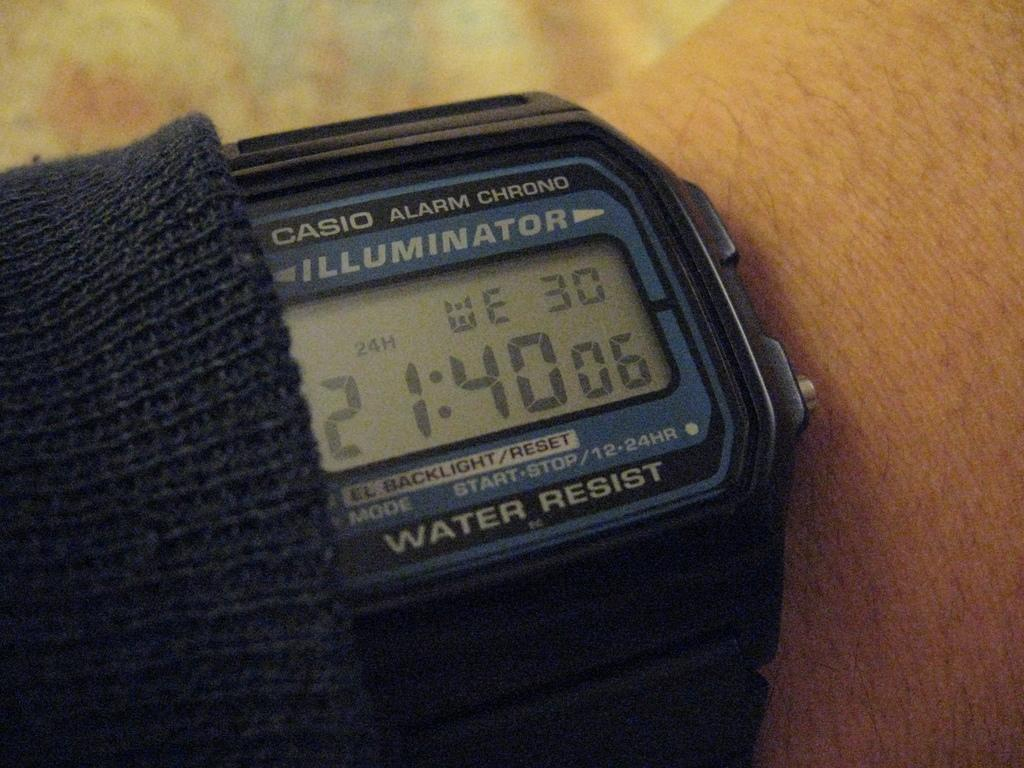<image>
Render a clear and concise summary of the photo. A digital wrist watch shows the time of 21:40. 